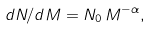<formula> <loc_0><loc_0><loc_500><loc_500>d N / d M = N _ { 0 } \, M ^ { - \alpha } ,</formula> 